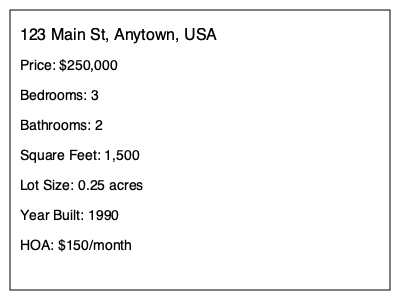Based on the real estate listing shown, what does "HOA" likely stand for, and what does the amount associated with it represent? To understand this real estate listing, let's break down the information step-by-step:

1. The listing shows various details about a property for sale.
2. At the bottom of the listing, we see "HOA: $150/month".
3. In U.S. real estate terminology, "HOA" stands for "Homeowners Association".
4. A Homeowners Association is an organization in many residential communities that makes and enforces rules for the properties and residents.
5. The amount listed ($150/month) represents the monthly fee that the homeowner must pay to the HOA.
6. This fee typically covers maintenance of common areas, amenities, and sometimes services like trash collection or snow removal.
7. HOA fees are an additional expense on top of the mortgage payment, property taxes, and insurance.

Understanding HOA fees is important for potential homebuyers, as it affects the total cost of owning the property.
Answer: Homeowners Association; monthly fee 